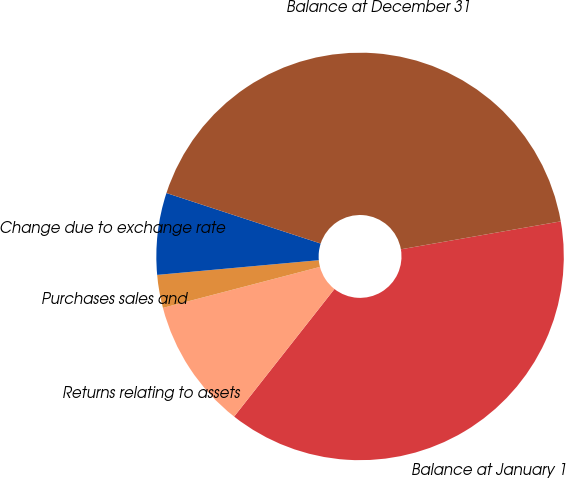Convert chart. <chart><loc_0><loc_0><loc_500><loc_500><pie_chart><fcel>Balance at January 1<fcel>Returns relating to assets<fcel>Purchases sales and<fcel>Change due to exchange rate<fcel>Balance at December 31<nl><fcel>38.36%<fcel>10.33%<fcel>2.62%<fcel>6.48%<fcel>42.21%<nl></chart> 